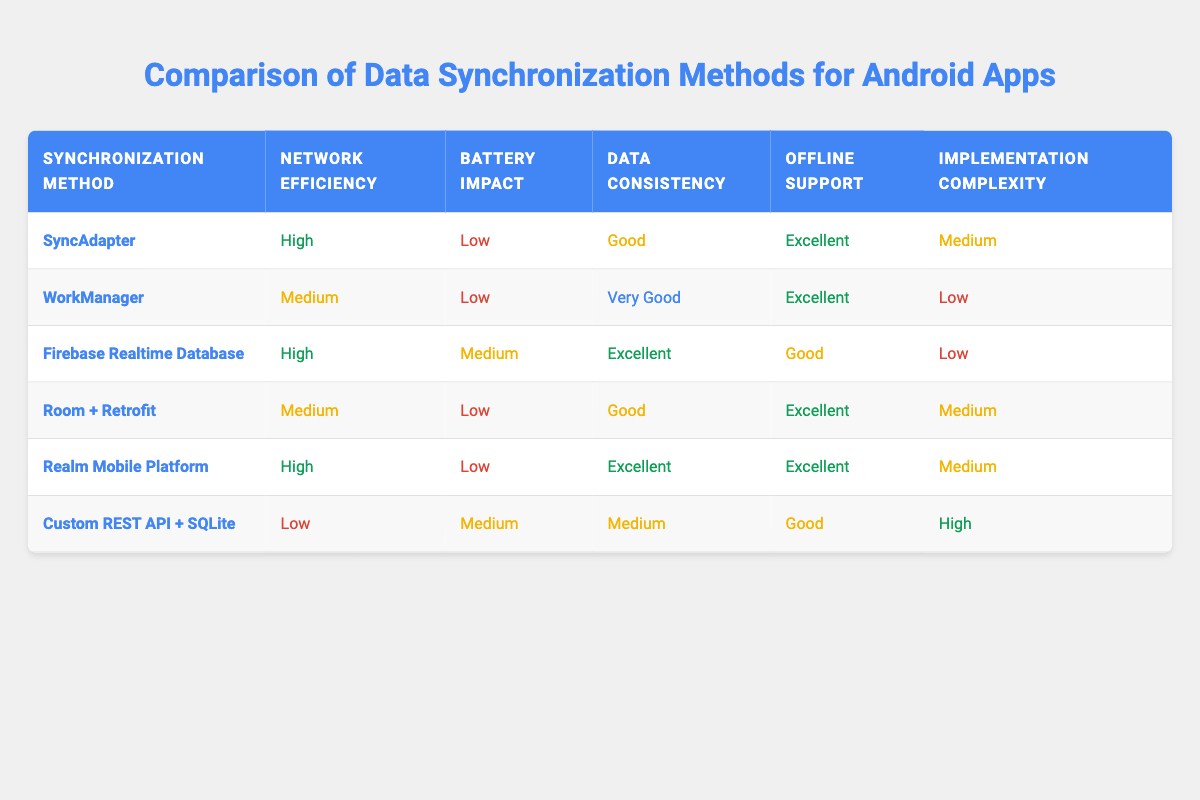What synchronization method has the highest network efficiency? By reviewing the table, the synchronization methods with the highest network efficiency are SyncAdapter, Firebase Realtime Database, and Realm Mobile Platform, all marked as "High."
Answer: SyncAdapter, Firebase Realtime Database, Realm Mobile Platform Which synchronization method has the lowest battery impact? The table lists the battery impact for each method. The methods with a "Low" impact are SyncAdapter, WorkManager, Room + Retrofit, and Realm Mobile Platform.
Answer: SyncAdapter, WorkManager, Room + Retrofit, Realm Mobile Platform Is the Firebase Realtime Database considered to have excellent data consistency? The data consistency for Firebase Realtime Database in the table shows "Excellent," confirming that it does indeed have excellent data consistency.
Answer: Yes What is the implementation complexity of the Custom REST API + SQLite method? The implementation complexity for Custom REST API + SQLite is categorized as "High," directly found in the table.
Answer: High Which method has both low battery impact and excellent offline support? Looking through the table, the methods that have both low battery impact and excellent offline support are SyncAdapter, WorkManager, and Room + Retrofit.
Answer: SyncAdapter, WorkManager, Room + Retrofit What is the difference in network efficiency between the Custom REST API + SQLite and SyncAdapter? The network efficiency for Custom REST API + SQLite is "Low," while for SyncAdapter it is "High." The difference is calculated as High (which signifies better efficiency) compared to Low.
Answer: High to Low How many synchronization methods have excellent offline support? From the table, we can see that the synchronization methods that have "Excellent" offline support are SyncAdapter, WorkManager, Realm Mobile Platform, and Room + Retrofit. There are four such methods.
Answer: Four Does the WorkManager have lower implementation complexity than the Firebase Realtime Database? The implementation complexity for WorkManager is "Low," whereas for Firebase Realtime Database it is "Low" as well. Since both are the same, the WorkManager is not lower.
Answer: No What percentage of synchronization methods listed show high network efficiency? Out of the 6 methods, 3 have "High" network efficiency. To find the percentage, (3/6) * 100 equals 50%.
Answer: 50% 